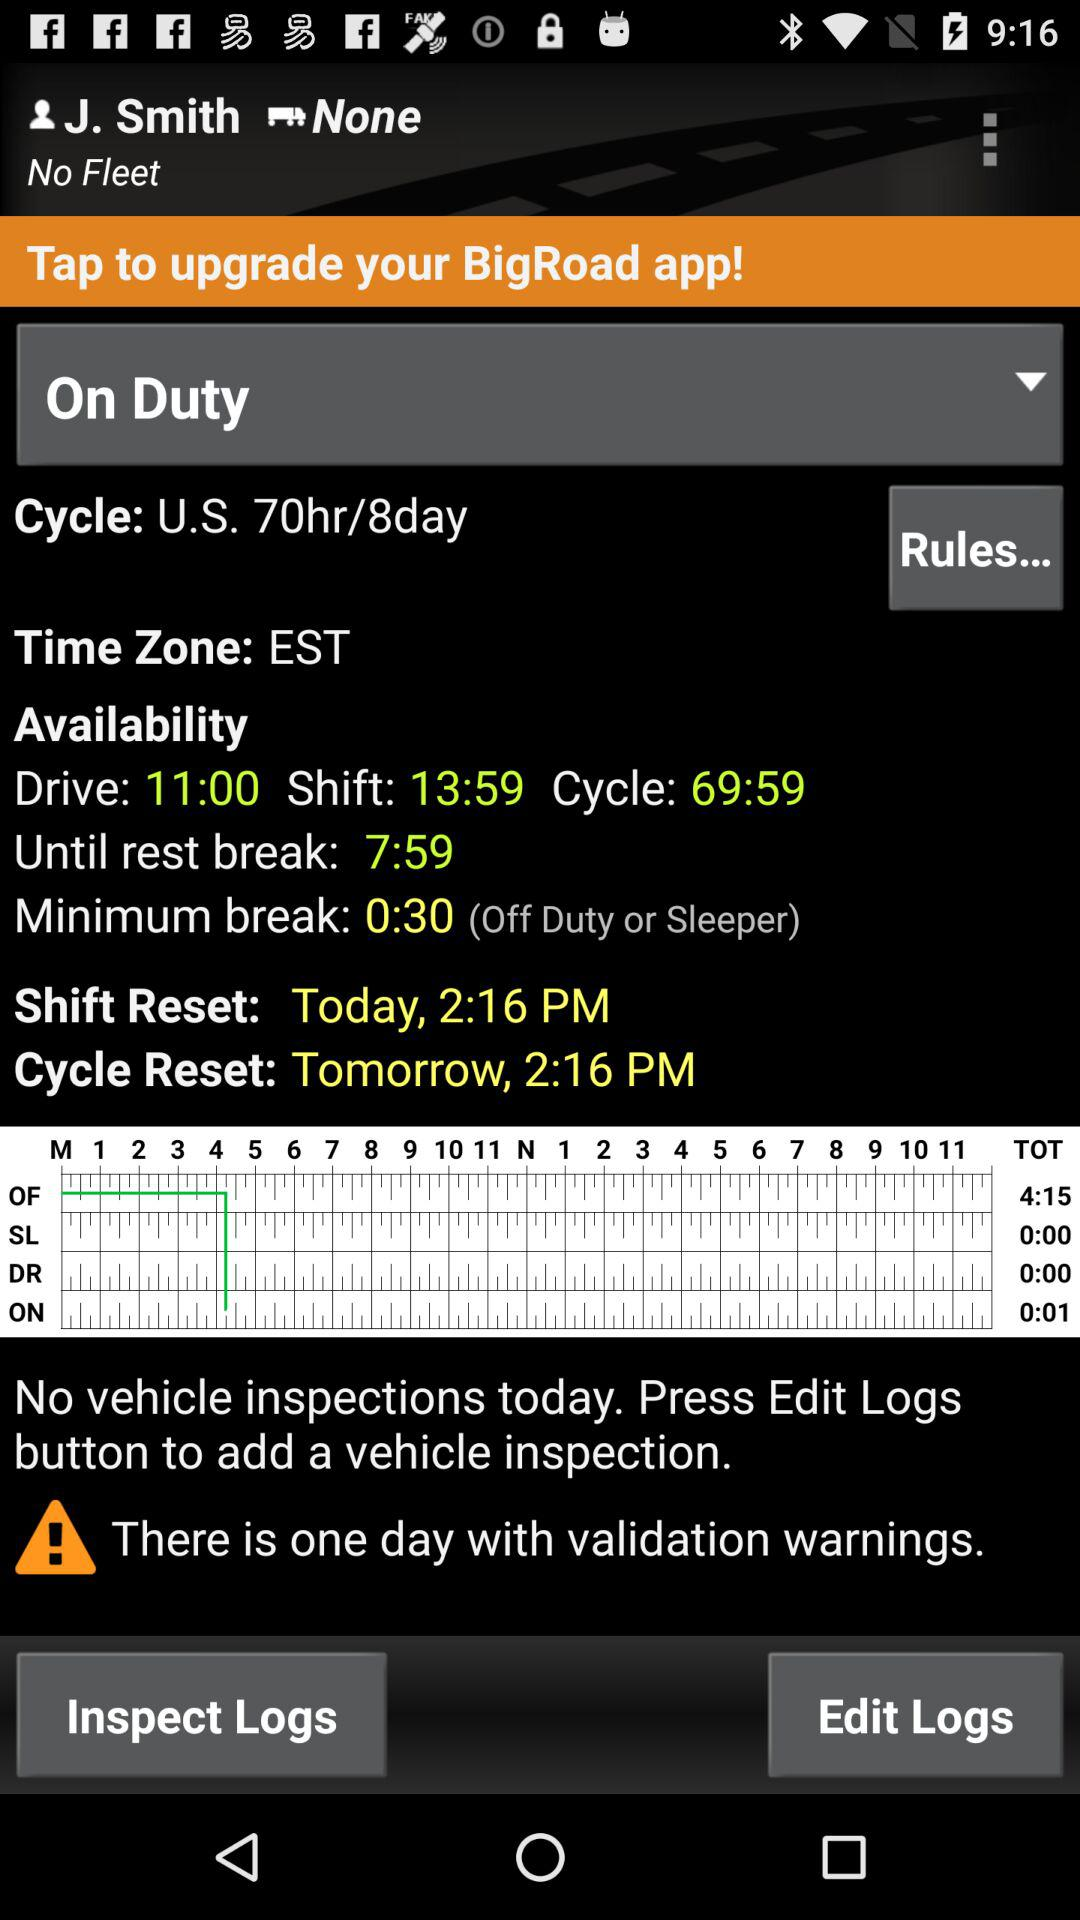What is the user name? The user name is J. Smith. 